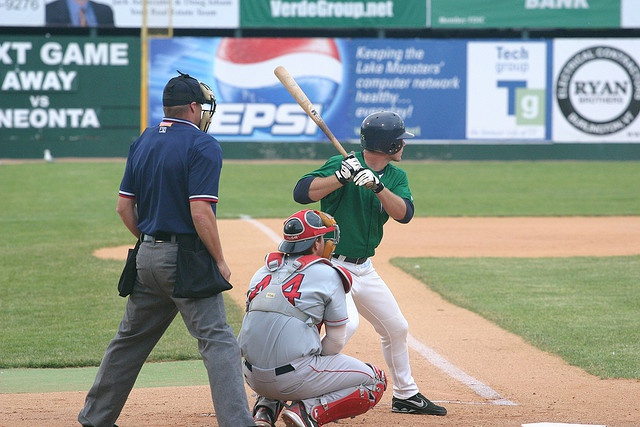Describe the objects in this image and their specific colors. I can see people in lightblue, black, gray, navy, and darkblue tones, people in lightblue, darkgray, gray, and lavender tones, people in lightblue, lavender, black, darkgray, and darkgreen tones, and baseball bat in lightblue, lightgray, darkgray, and tan tones in this image. 